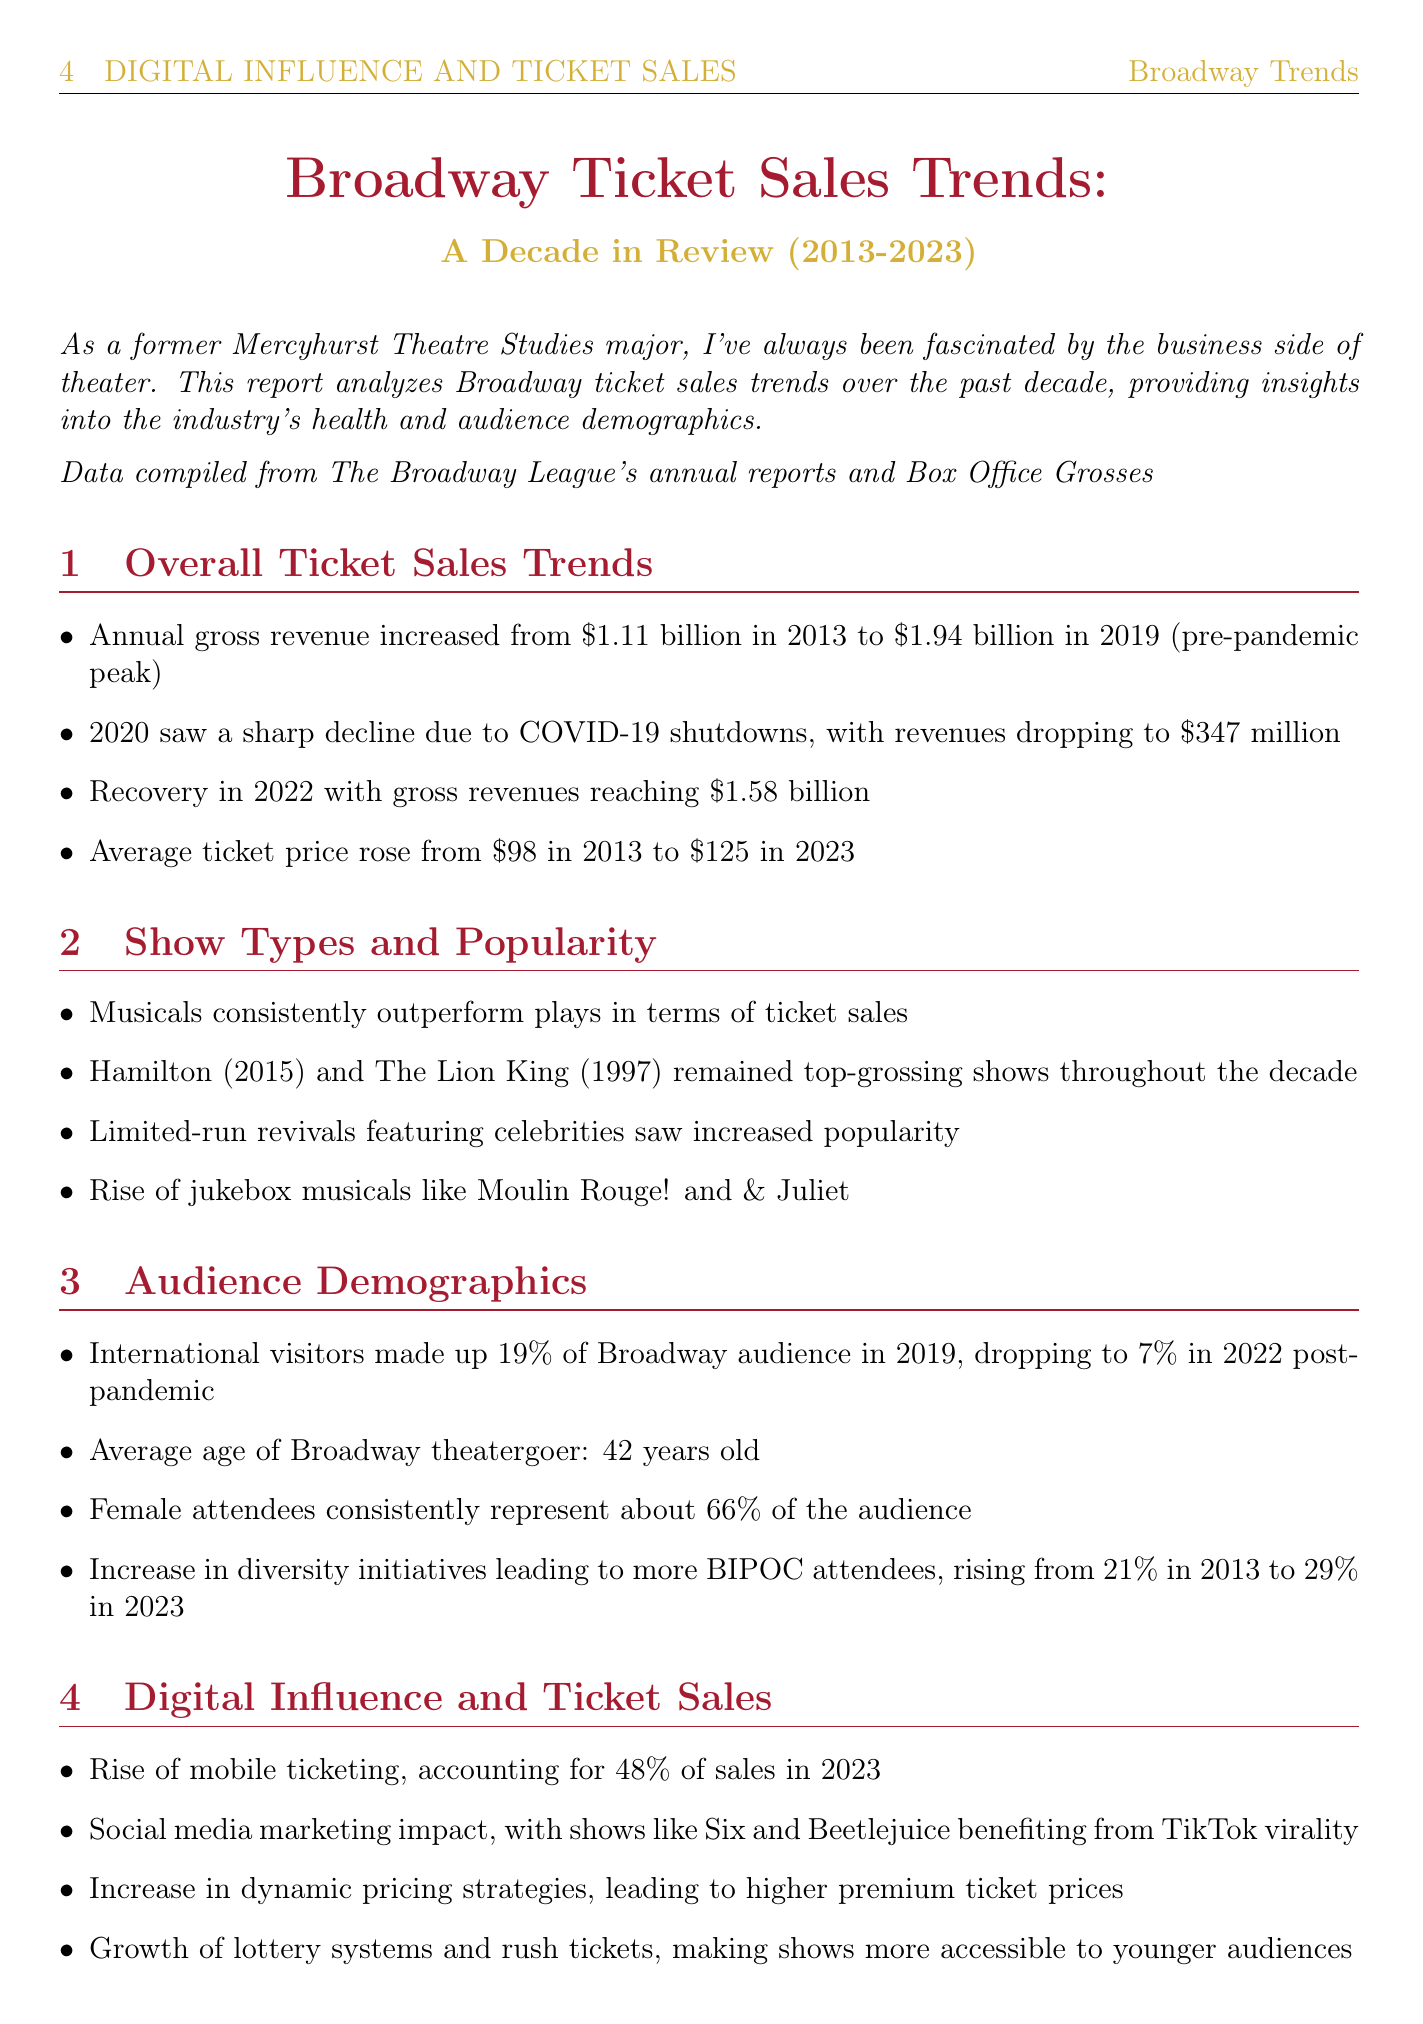What was the annual gross revenue in 2013? The document states that the annual gross revenue was $1.11 billion in 2013.
Answer: $1.11 billion What was the average ticket price in 2023? The document mentions that the average ticket price rose to $125 in 2023.
Answer: $125 What percentage of the audience were international visitors in 2019? The document indicates that international visitors made up 19% of the Broadway audience in 2019.
Answer: 19% Which show debuted in 2015 and set new records for advance sales? The document refers to Hamilton, which debuted in 2015 and set new records.
Answer: Hamilton What type of shows consistently outperform plays? The document notes that musicals consistently outperform plays in terms of ticket sales.
Answer: Musicals What event caused a sharp decline in revenue in 2020? The document explains that the COVID-19 pandemic shutdown caused a sharp decline in revenue in 2020.
Answer: COVID-19 pandemic shutdown What is the anticipated timeline for full recovery to pre-pandemic levels? The document states that full recovery is anticipated by 2024.
Answer: 2024 What percentage of the audience were BIPOC attendees in 2023? The document specifies that BIPOC attendees rose to 29% in 2023.
Answer: 29% 